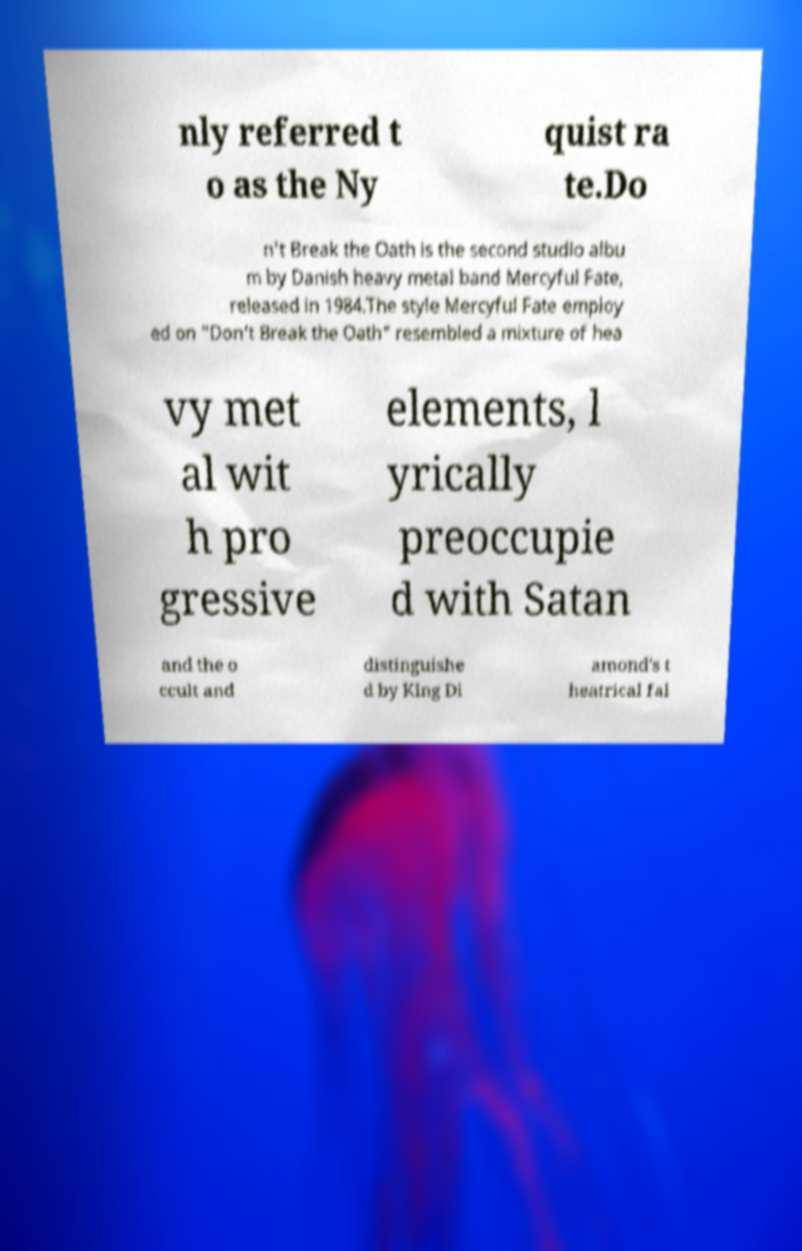Can you accurately transcribe the text from the provided image for me? nly referred t o as the Ny quist ra te.Do n't Break the Oath is the second studio albu m by Danish heavy metal band Mercyful Fate, released in 1984.The style Mercyful Fate employ ed on "Don't Break the Oath" resembled a mixture of hea vy met al wit h pro gressive elements, l yrically preoccupie d with Satan and the o ccult and distinguishe d by King Di amond's t heatrical fal 